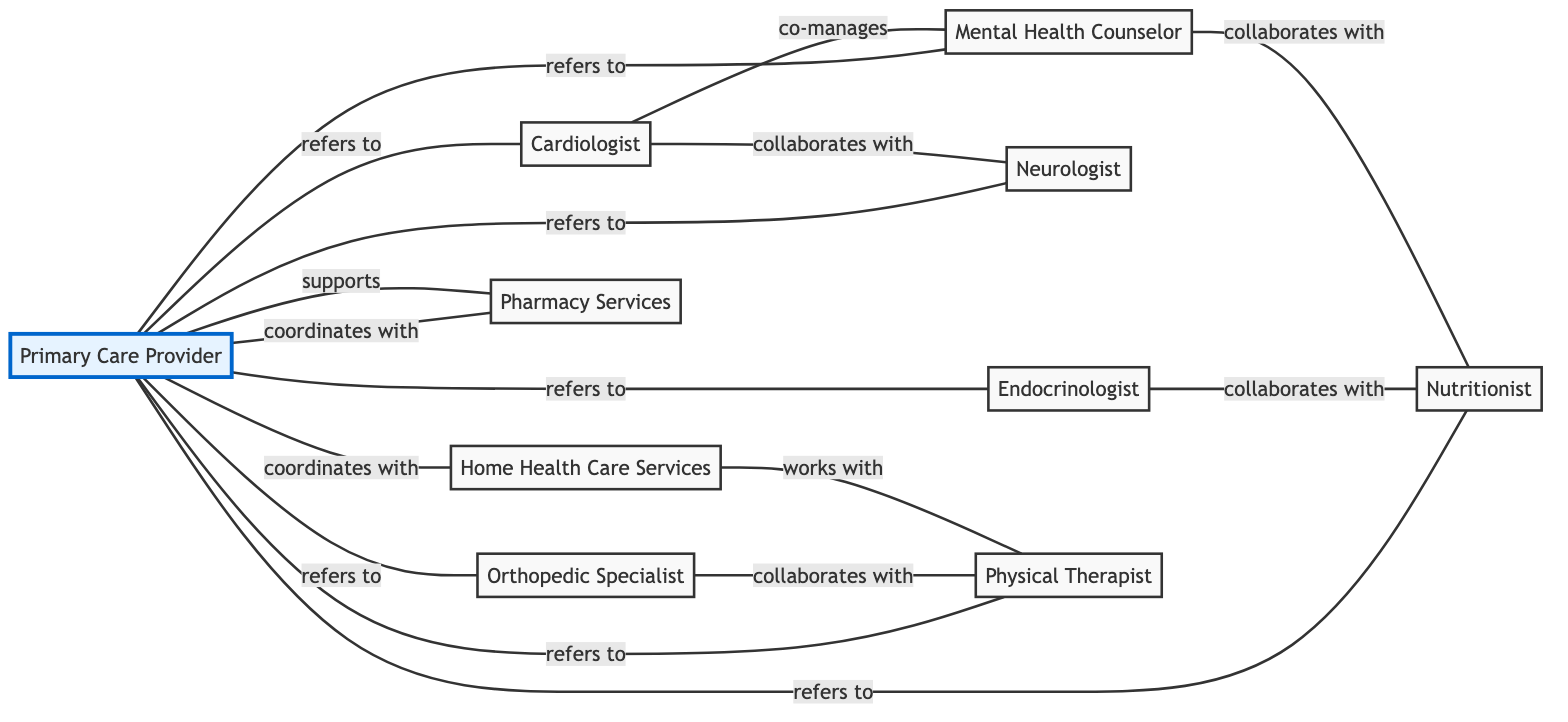What is the total number of nodes in the diagram? The diagram contains 10 unique entities, each representing a specialized medical service or role within the referral network.
Answer: 10 How many edges are there connecting the Primary Care Provider to other nodes? The Primary Care Provider (node 1) has edges connecting to 8 other nodes, displaying various referral and coordination relationships.
Answer: 8 Which specialist collaborates with the Neurologist? The diagram shows that the Neurologist (node 5) collaborates with the Cardiologist (node 2) through their edge relationship.
Answer: Cardiologist What relationship does the Endocrinologist have with the Nutritionist? The Endocrinologist (node 3) collaborates with the Nutritionist (node 7) as indicated by the directed edge between them.
Answer: collaborates with Which node supports the Primary Care Provider? According to the diagram, Pharmacy Services (node 10) is the node that supports the Primary Care Provider (node 1).
Answer: Pharmacy Services Which two nodes coordinate together based on the diagram? Home Health Care Services (node 9) and Pharmacy Services (node 10) both coordinate with the Primary Care Provider (node 1) as indicated by their respective edges.
Answer: Home Health Care Services, Pharmacy Services How many nodes are directly referred to by the Primary Care Provider? The Primary Care Provider has direct referral relationships with 8 nodes in the diagram, highlighting its extensive reach within the referral network.
Answer: 8 Which specialist co-manages with the Cardiologist? The relationship established in the diagram indicates that the Mental Health Counselor (node 6) co-manages with the Cardiologist (node 2).
Answer: Mental Health Counselor What is the connection between Physical Therapist and Home Health Care Services? The diagram indicates that the Physical Therapist (node 8) works with Home Health Care Services (node 9), showing a collaboration in the care process.
Answer: works with 